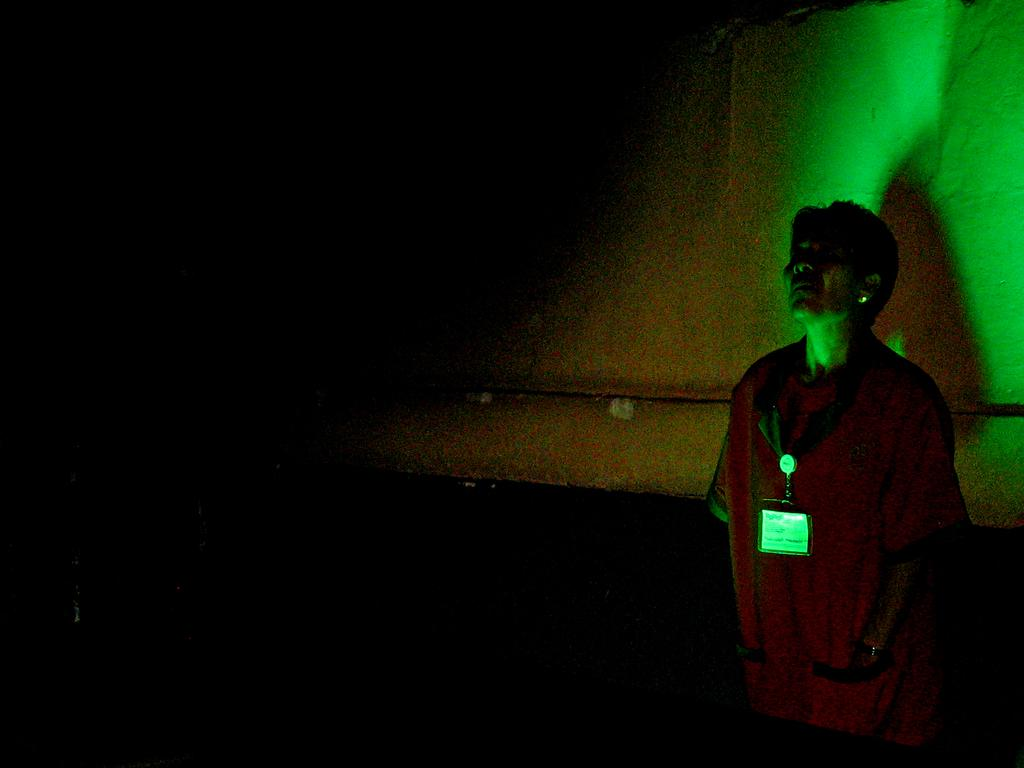What time of day is depicted in the image? The image is taken during night time. Can you describe the person in the image? There is a person in the image, and they are wearing an identity card. What is the person's posture in the image? The person is standing in the image. What can be seen behind the person? There is a wall visible behind the person. What type of shade is covering the person in the image? There is no shade covering the person in the image, as it is taken during night time. What is the condition of the roof in the image? There is no roof present in the image, only a wall visible behind the person. 